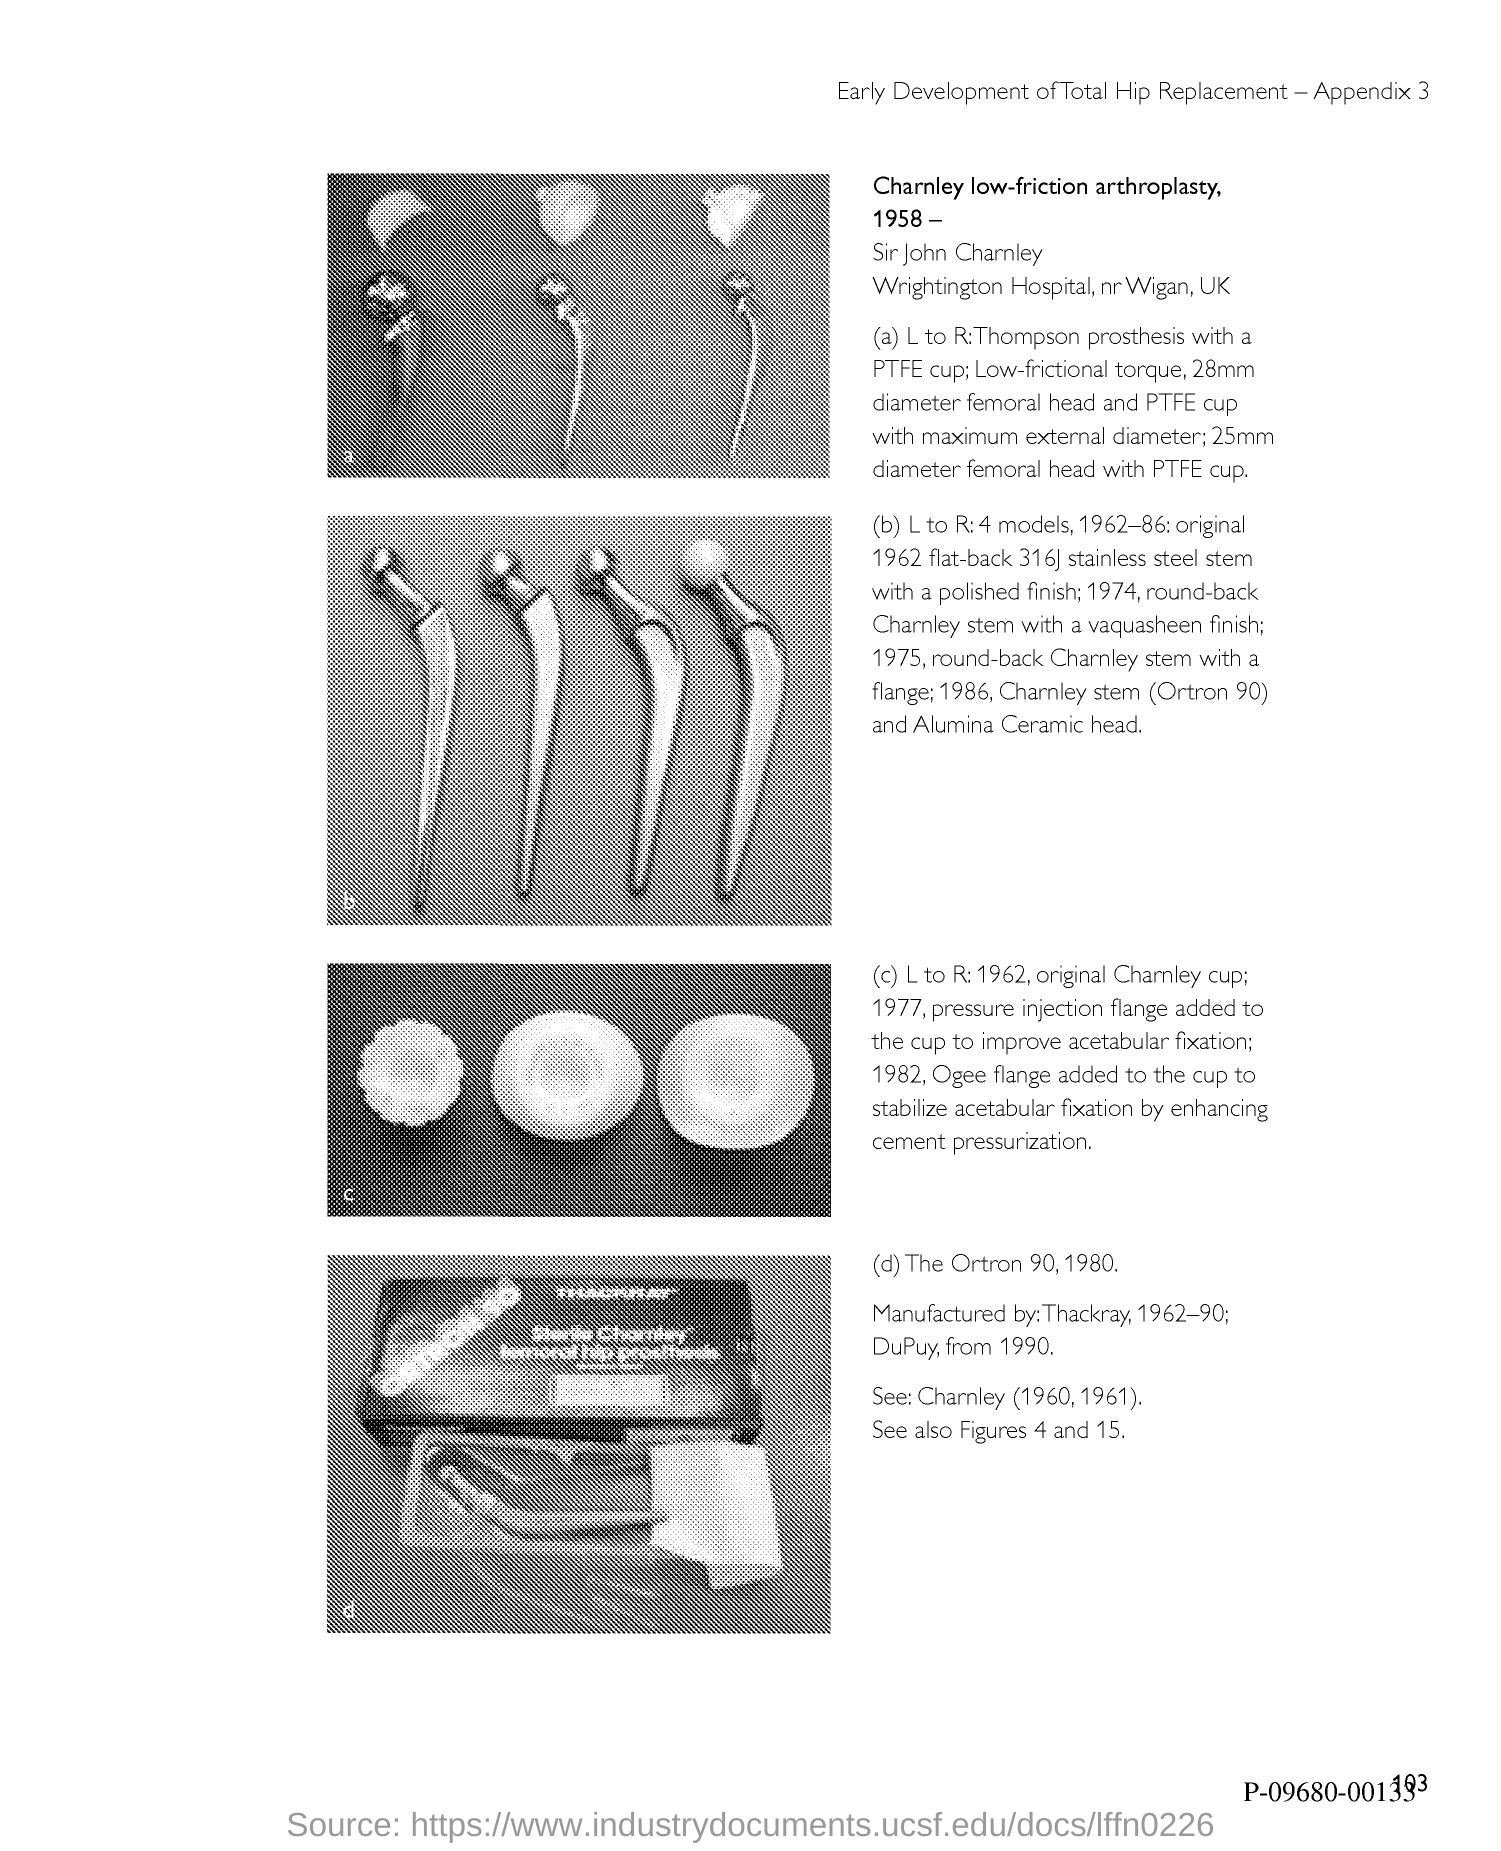What is the appendix no.?
Your answer should be compact. 3. 